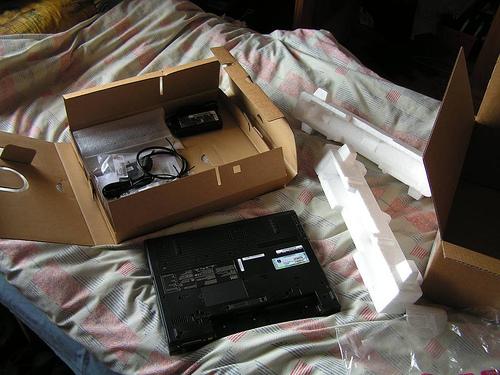What is the price of this piece of electronic item?
Quick response, please. $500. What are the white tubes made of?
Concise answer only. Styrofoam. What's the packaging?
Concise answer only. Cardboard. 